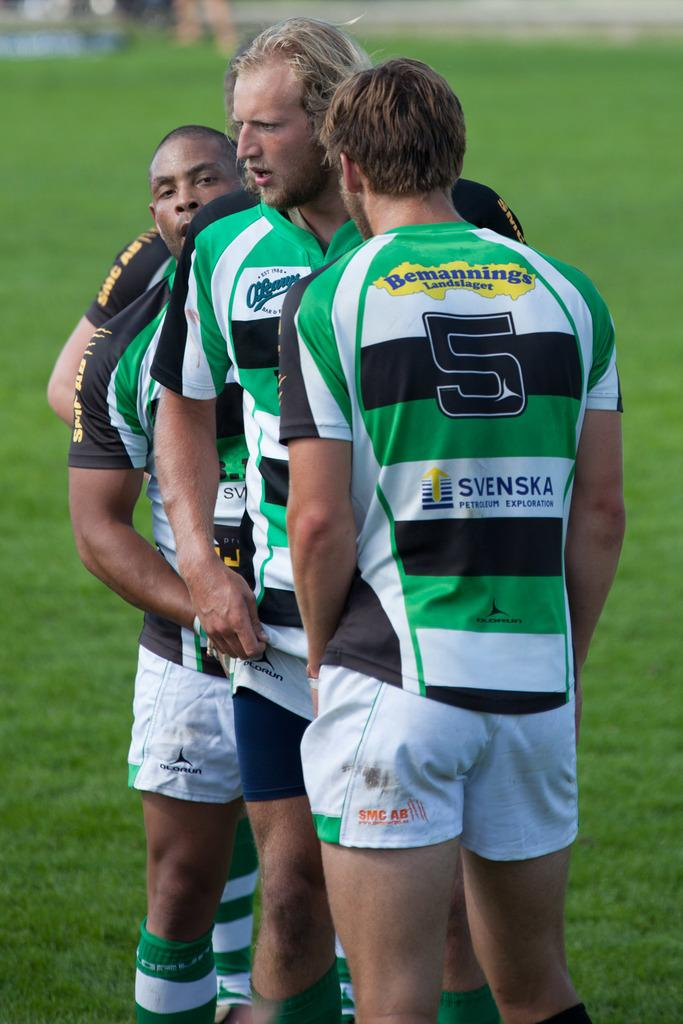<image>
Render a clear and concise summary of the photo. Three athletes on a field wearing green striped shirts with the number 5 on the first one. 